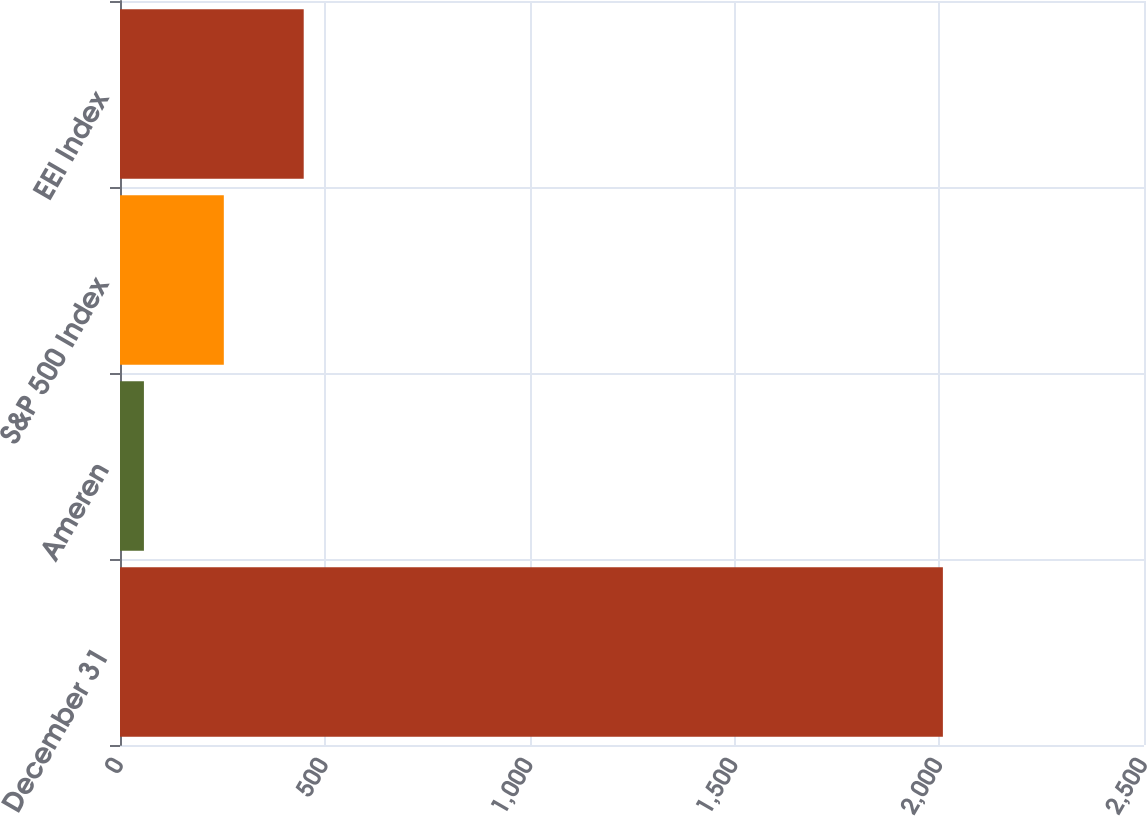<chart> <loc_0><loc_0><loc_500><loc_500><bar_chart><fcel>December 31<fcel>Ameren<fcel>S&P 500 Index<fcel>EEI Index<nl><fcel>2009<fcel>58.4<fcel>253.46<fcel>448.52<nl></chart> 